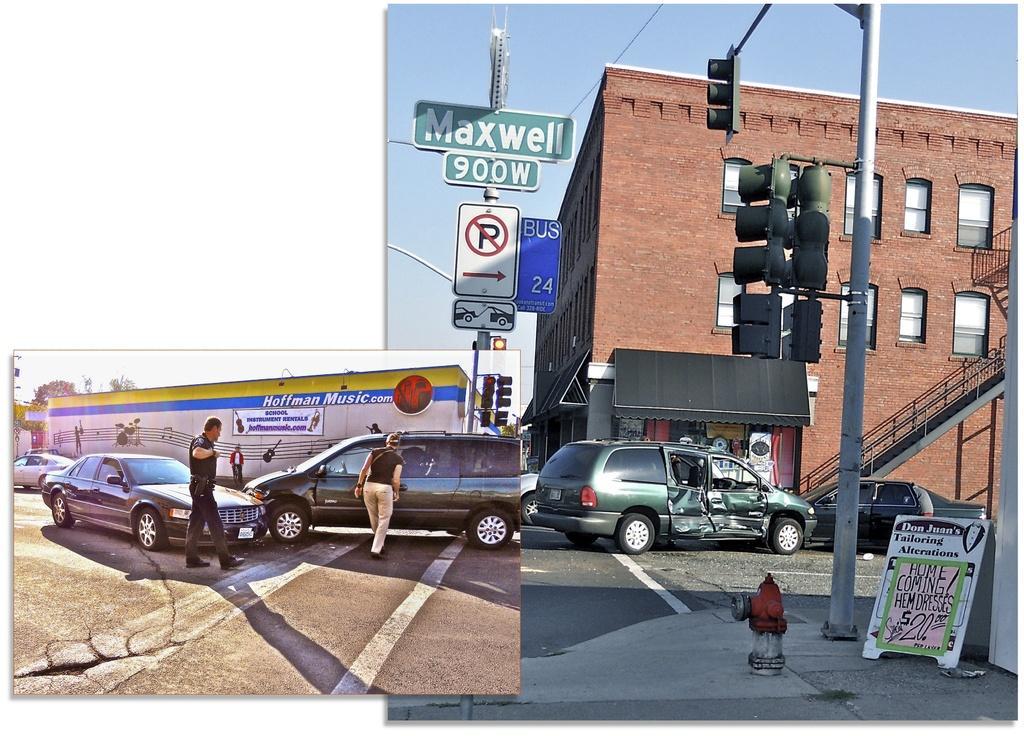Describe this image in one or two sentences. This image consists of two images. On the right image, there are cars, buildings, traffic signals, sign boards, road, hydrant, poster, person, staircase, building, sky. On the left image, there are cars, people, wall, text, trees, road, traffic signals, sky. 